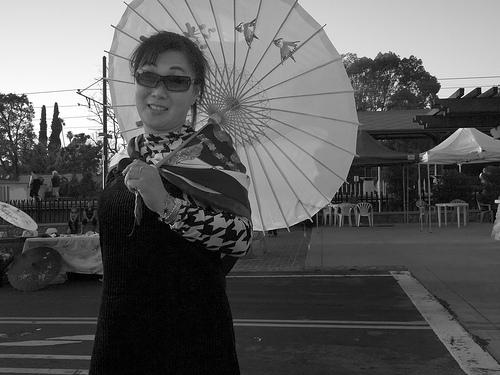Question: what is she holding?
Choices:
A. A phone.
B. A umbrella.
C. A purse.
D. A shopping bag.
Answer with the letter. Answer: B Question: what is she doing?
Choices:
A. Smirking.
B. Frowning.
C. Crying.
D. Smiling.
Answer with the letter. Answer: D Question: who is in the back of the lady?
Choices:
A. Man.
B. Children.
C. Animals.
D. People.
Answer with the letter. Answer: D Question: why is she smiling?
Choices:
A. At the man.
B. She is happy.
C. She got good news.
D. For the picture.
Answer with the letter. Answer: D 